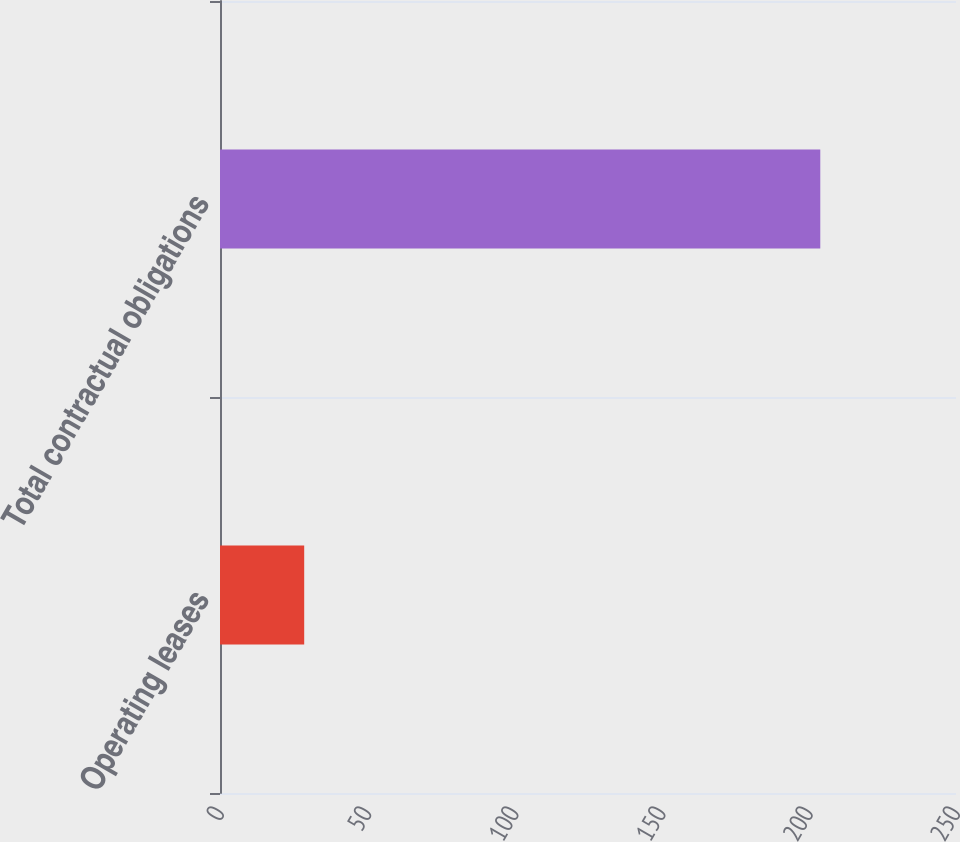<chart> <loc_0><loc_0><loc_500><loc_500><bar_chart><fcel>Operating leases<fcel>Total contractual obligations<nl><fcel>28.6<fcel>203.9<nl></chart> 